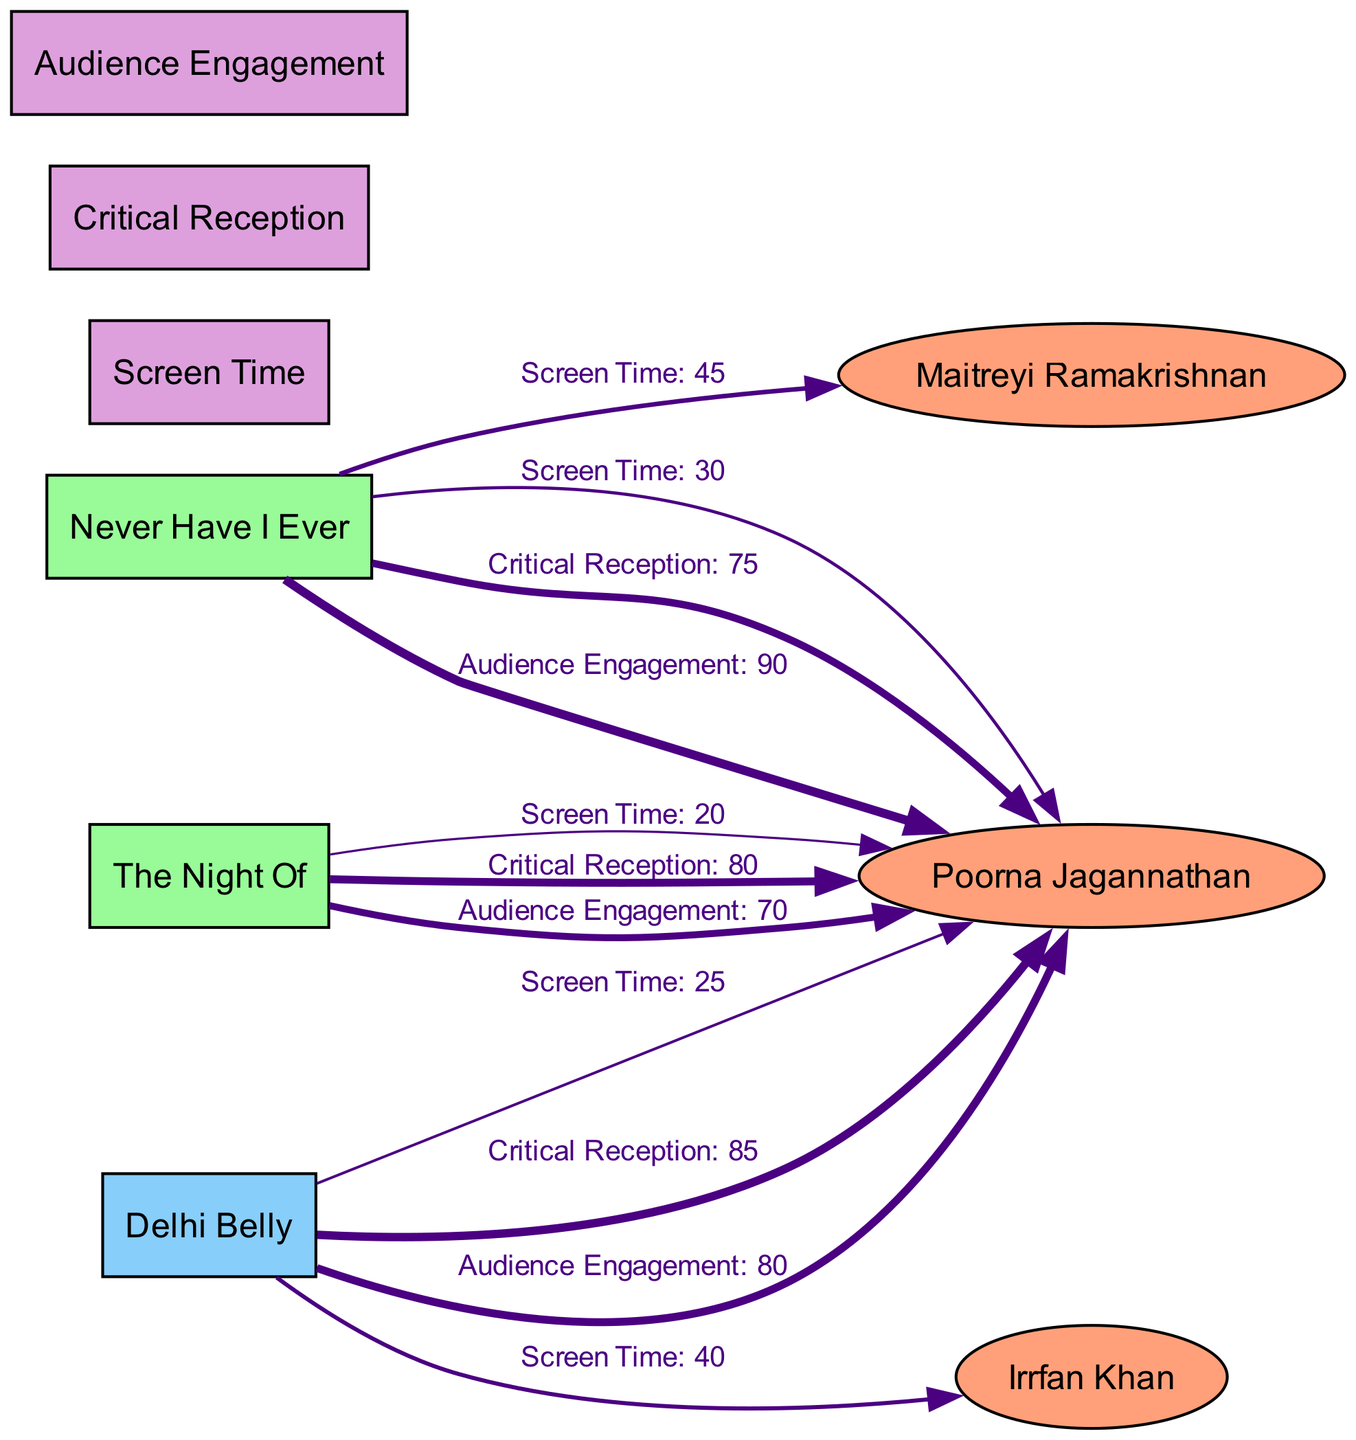What is the screen time of Poorna Jagannathan in "Never Have I Ever"? The diagram shows an edge from "Never Have I Ever" to "Poorna Jagannathan" labeled "Screen Time" with a value of 30.
Answer: 30 What is the critical reception score for Poorna Jagannathan in "Delhi Belly"? According to the diagram, the edge connecting "Delhi Belly" to "Poorna Jagannathan" labeled "Critical Reception" has a value of 85.
Answer: 85 How many actors are represented in this diagram? The diagram includes three actors: Poorna Jagannathan, Maitreyi Ramakrishnan, and Irrfan Khan, totaling three nodes of type "actor".
Answer: 3 Which film has Maitreyi Ramakrishnan as a co-star? The edge from "Never Have I Ever" to "Maitreyi Ramakrishnan" represents that film, indicating she is attached to that series.
Answer: Never Have I Ever In which film does Poorna Jagannathan have the highest audience engagement? The edge for "Audience Engagement" from "Delhi Belly" to "Poorna Jagannathan" has a value of 80, while "Never Have I Ever" has 90, indicating the highest is for "Never Have I Ever".
Answer: Never Have I Ever What is the screen time value for Irrfan Khan in "Delhi Belly"? The diagram has an edge from "Delhi Belly" to "Irrfan Khan" labeled "Screen Time" with a value of 40.
Answer: 40 How does Poorna Jagannathan's critical reception in "The Night Of" compare to her performance in "Delhi Belly"? "The Night Of" has a critical reception of 80 and "Delhi Belly" has 85. Comparing these values shows that the latter is higher, indicating better reception.
Answer: Delhi Belly What metric indicates Poorna Jagannathan's performance in "The Night Of"? The diagram indicates a critical reception value of 80 for Poorna Jagannathan in "The Night Of".
Answer: 80 Which co-star has the least screen time compared to Poorna Jagannathan in "Never Have I Ever"? Poorna Jagannathan has 30 units of screen time, while Maitreyi Ramakrishnan has 45, making her the one with less screen time.
Answer: Poorna Jagannathan 